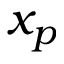Convert formula to latex. <formula><loc_0><loc_0><loc_500><loc_500>x _ { p }</formula> 